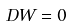<formula> <loc_0><loc_0><loc_500><loc_500>D W = 0</formula> 